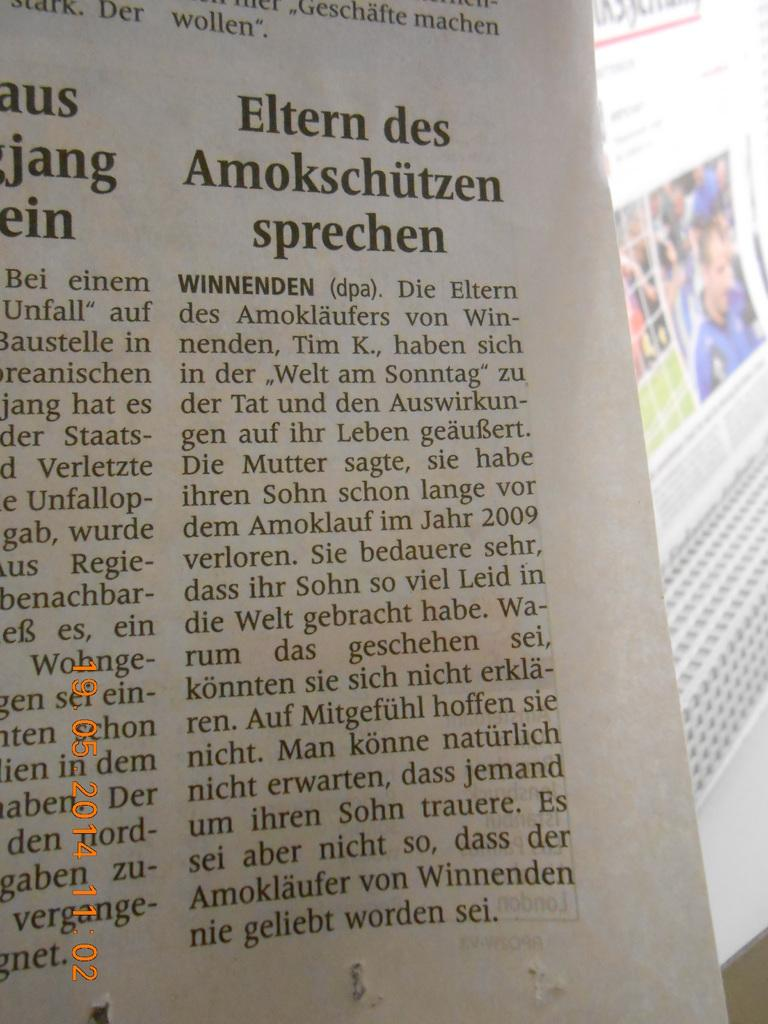<image>
Give a short and clear explanation of the subsequent image. Elten des Amokschutzen Sprechen news letter in black 